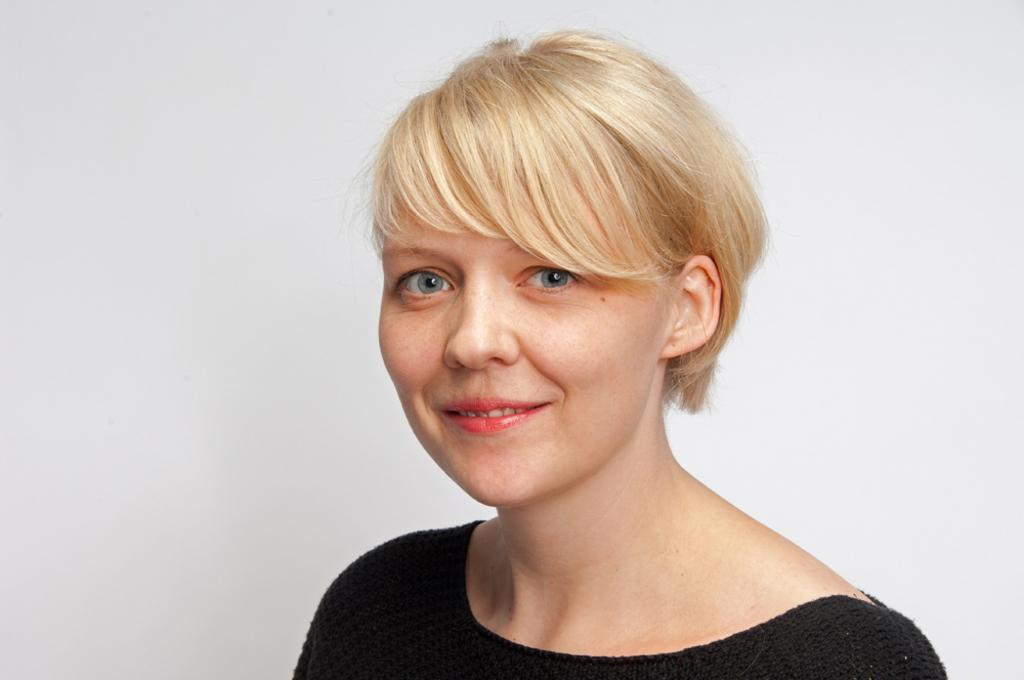Who is the main subject in the image? There is a woman in the image. What is the woman doing in the image? The woman is smiling. What color are the clothes the woman is wearing? The woman is wearing black clothes. What is the color of the background in the image? The background of the image is white in color. Can you tell me how many frogs are present in the image? There are no frogs present in the image; it features a woman wearing black clothes against a white background. 